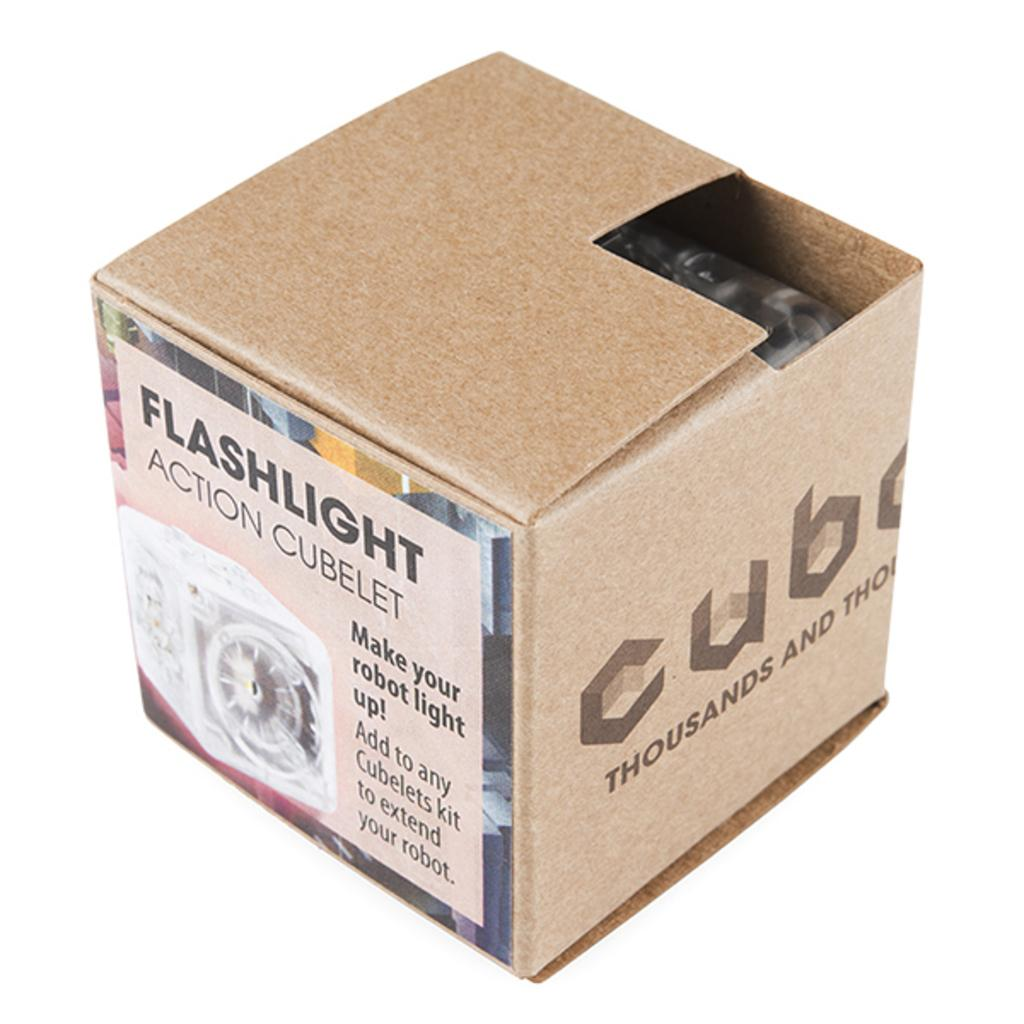<image>
Give a short and clear explanation of the subsequent image. A beige carboard box which says it contains a Flahlight Action Cubelet. 